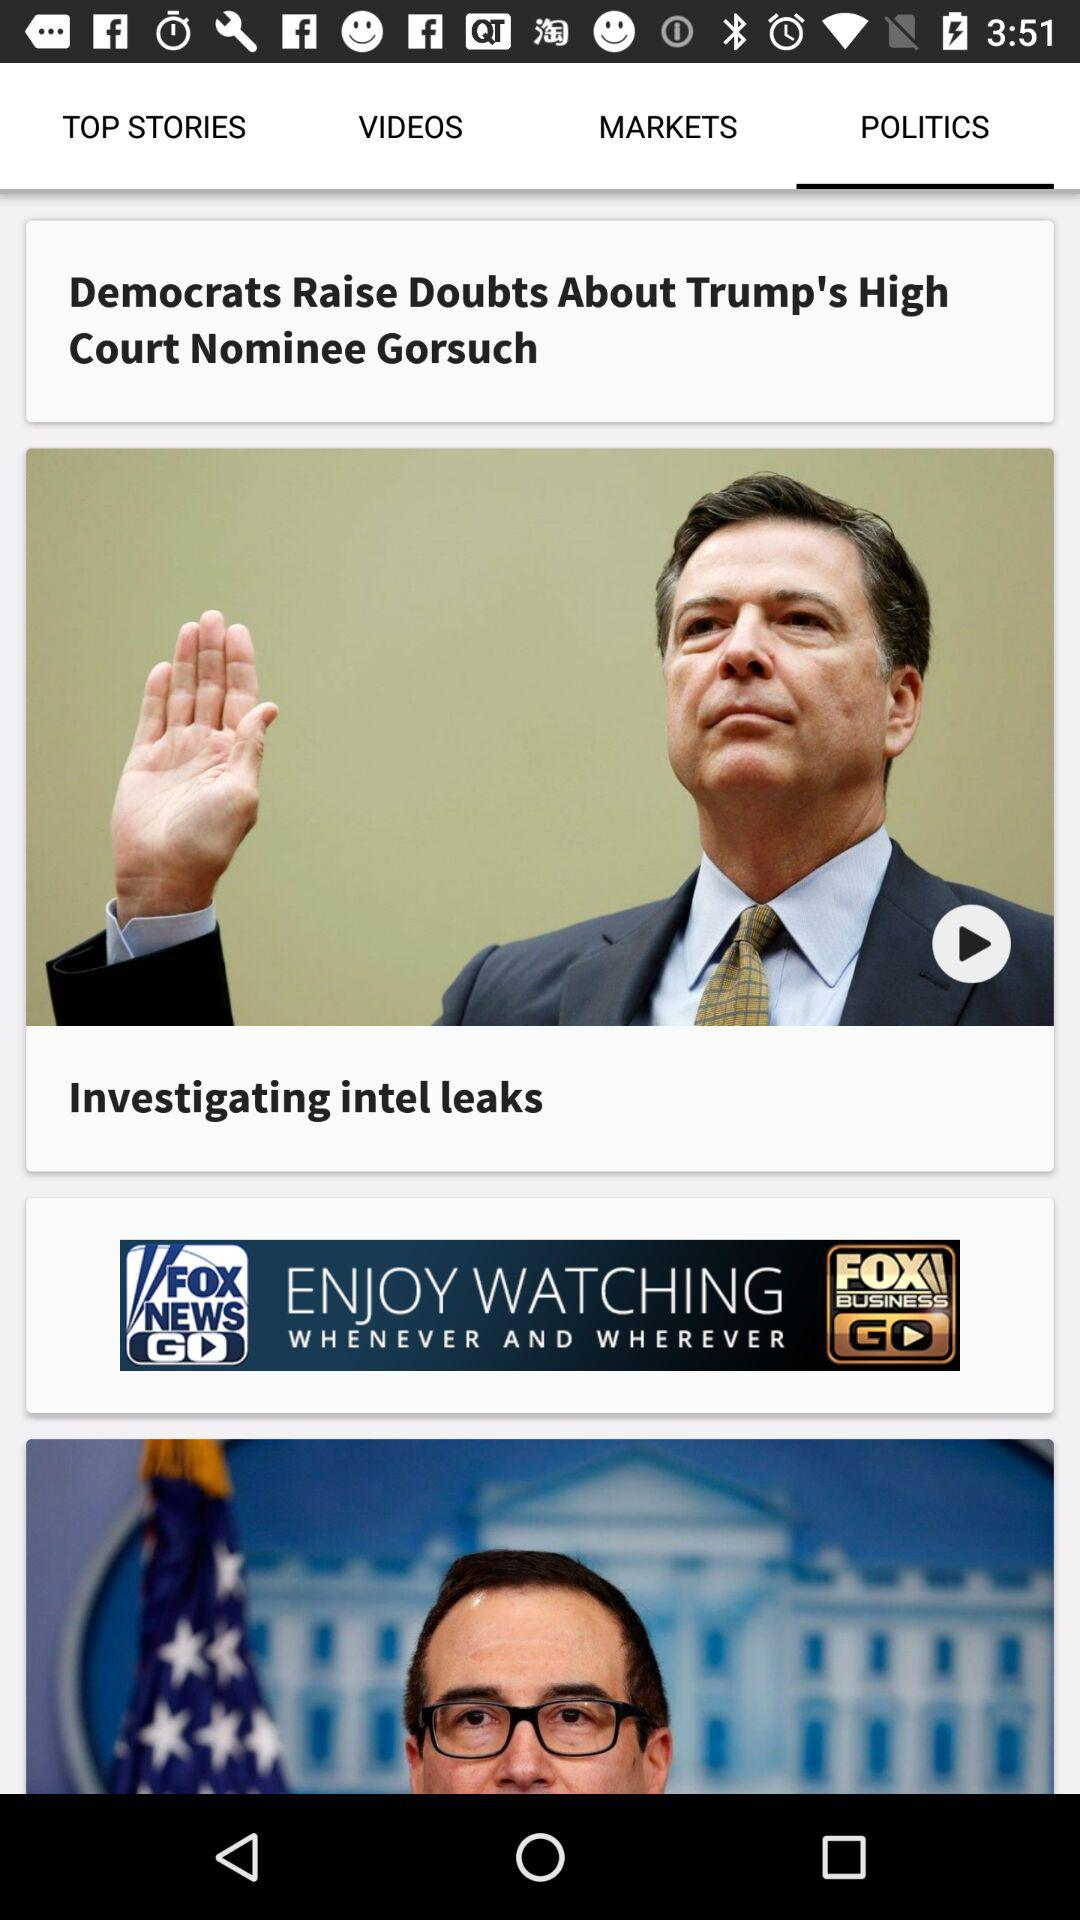Which tab is selected? The selected tab is "POLITICS". 